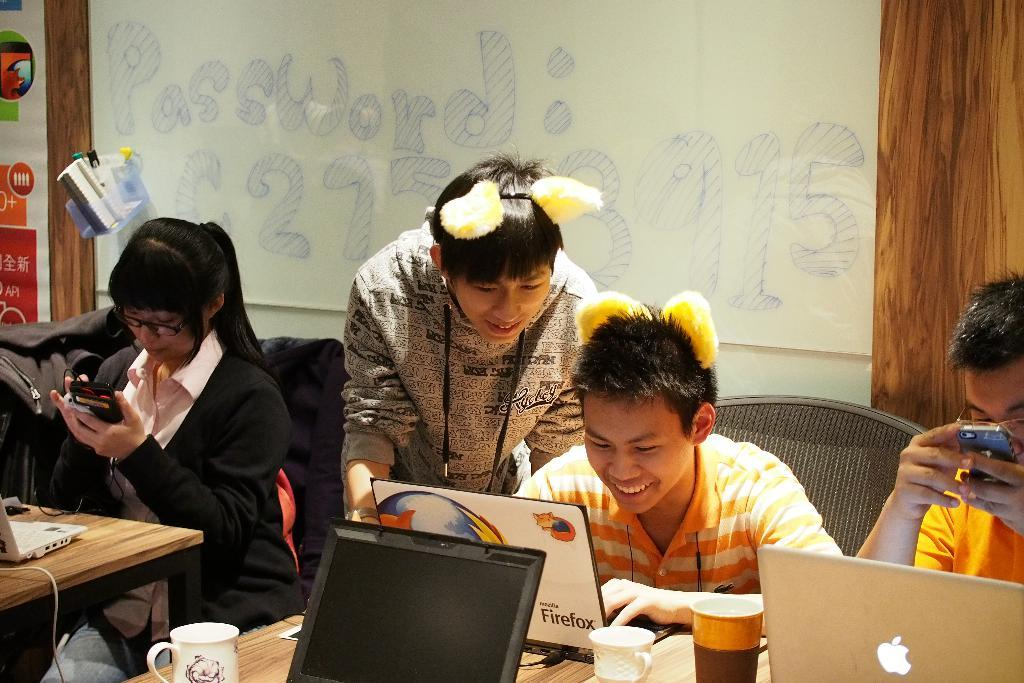What can be seen in the foreground of the picture? In the foreground of the picture, there are people, laptops, a table, cups, chairs, and bags. There are also other objects present. What is the primary purpose of the objects in the foreground? The laptops, cups, and bags suggest that the people in the foreground might be working or studying, as they are using laptops and have drinks and bags nearby. What can be seen in the background of the picture? In the background of the picture, there is a board, a wall, a poster, pens, and other objects. What might the board in the background be used for? The board in the background might be used for displaying information, writing notes, or presenting ideas during a meeting or class. What type of humor can be seen on the wrist of the person in the image? There is no indication of humor or any object on a wrist in the image. Is there a mask visible on the poster in the background of the image? There is no mention of a mask in the provided facts, and no mask is visible on the poster in the image. 